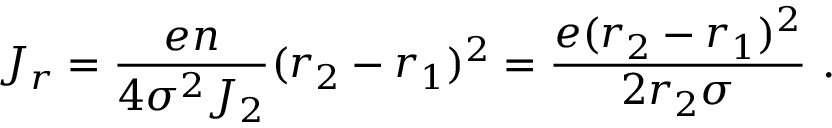Convert formula to latex. <formula><loc_0><loc_0><loc_500><loc_500>J _ { r } = { \frac { e n } { 4 \sigma ^ { 2 } J _ { 2 } } } ( r _ { 2 } - r _ { 1 } ) ^ { 2 } = { \frac { e ( r _ { 2 } - r _ { 1 } ) ^ { 2 } } { 2 r _ { 2 } \sigma } } .</formula> 